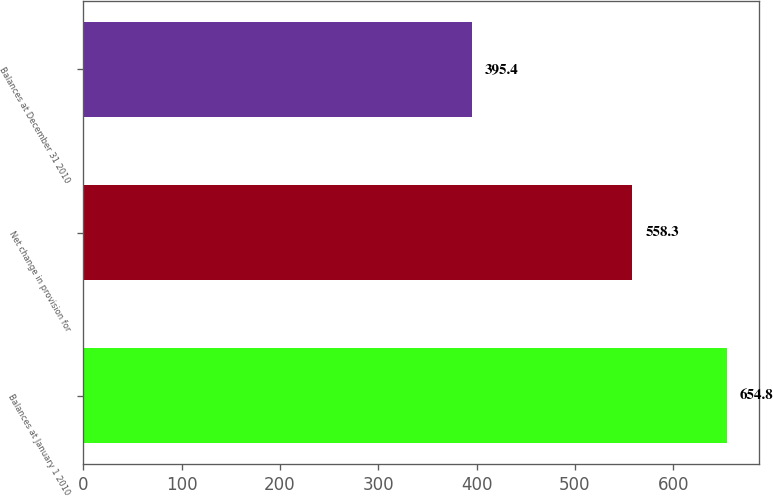Convert chart to OTSL. <chart><loc_0><loc_0><loc_500><loc_500><bar_chart><fcel>Balances at January 1 2010<fcel>Net change in provision for<fcel>Balances at December 31 2010<nl><fcel>654.8<fcel>558.3<fcel>395.4<nl></chart> 